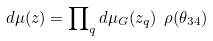Convert formula to latex. <formula><loc_0><loc_0><loc_500><loc_500>d \mu ( z ) = \prod \nolimits _ { q } d \mu _ { G } ( z _ { q } ) \ \rho ( \theta _ { 3 4 } )</formula> 